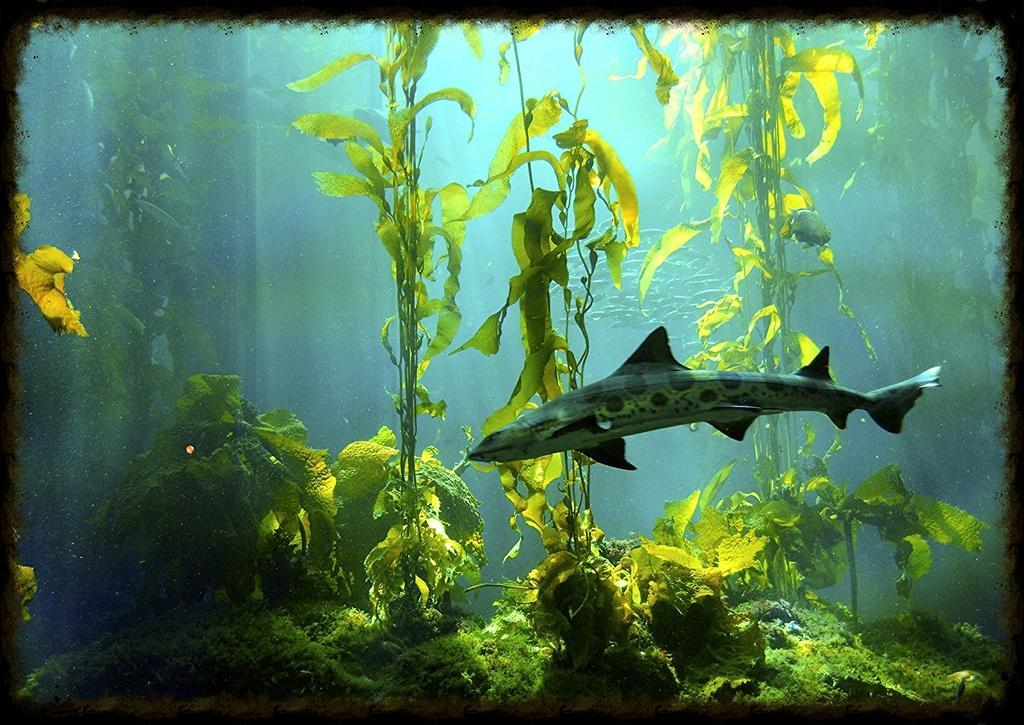How would you summarize this image in a sentence or two? In the picture we can see water plants and fish in the water. 